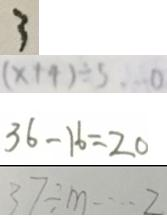Convert formula to latex. <formula><loc_0><loc_0><loc_500><loc_500>3 
 ( x + 4 ) \div 5 \cdots 0 
 3 6 - 1 6 = 2 0 
 3 7 \div m \cdots 2</formula> 